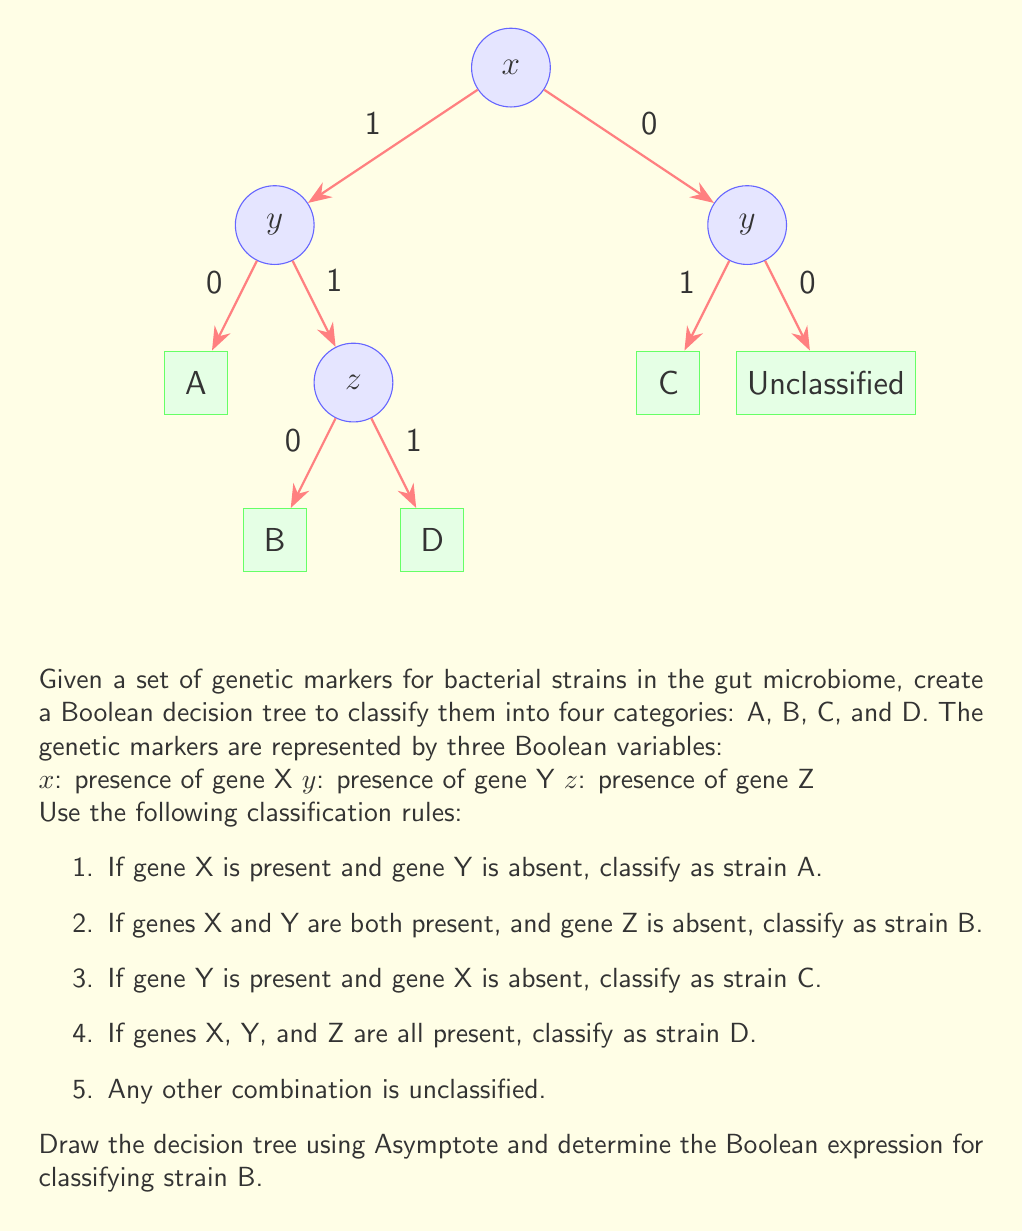Can you answer this question? To solve this problem, we'll follow these steps:

1. Analyze the decision tree:
   The decision tree represents the classification rules using Boolean logic. Each node represents a decision based on the presence (1) or absence (0) of a genetic marker.

2. Trace the path for strain B:
   To classify a bacterial strain as B, we need:
   - $x = 1$ (gene X is present)
   - $y = 1$ (gene Y is present)
   - $z = 0$ (gene Z is absent)

3. Construct the Boolean expression:
   The Boolean expression for strain B is the logical AND of these conditions:
   $$ B = x \wedge y \wedge \neg z $$

   Where:
   $\wedge$ represents logical AND
   $\neg$ represents logical NOT

4. Verify the expression:
   - If $x = 1$, $y = 1$, and $z = 0$, then $B = 1 \wedge 1 \wedge 1 = 1$ (classified as strain B)
   - Any other combination will result in $B = 0$ (not classified as strain B)

5. Simplify the expression:
   The given expression is already in its simplest form, as it directly represents the conditions for classifying strain B.
Answer: $x \wedge y \wedge \neg z$ 